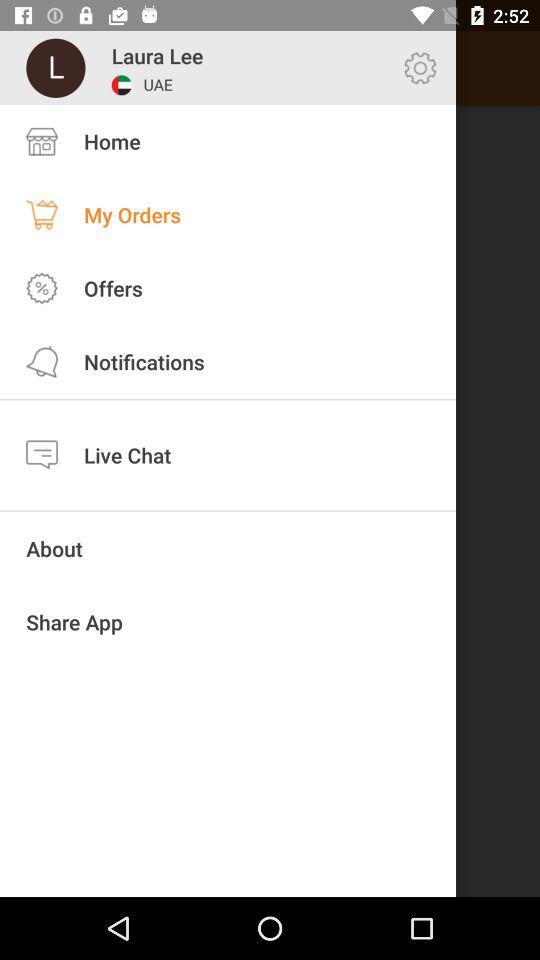What is the country name of the user? The country name of the user is UAE. 